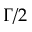<formula> <loc_0><loc_0><loc_500><loc_500>\Gamma / 2</formula> 